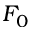<formula> <loc_0><loc_0><loc_500><loc_500>F _ { 0 }</formula> 